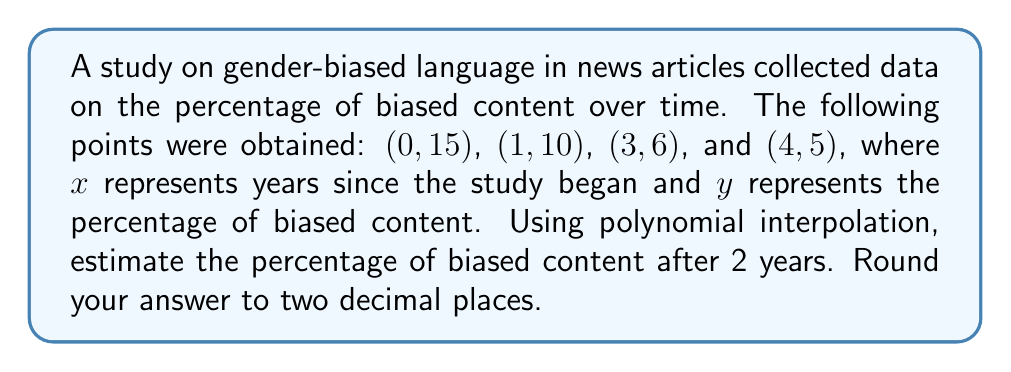Can you answer this question? Let's approach this step-by-step using Lagrange interpolation:

1) The Lagrange interpolation polynomial is given by:

   $$P(x) = \sum_{i=0}^n y_i \cdot L_i(x)$$

   where $L_i(x) = \prod_{j=0, j \neq i}^n \frac{x - x_j}{x_i - x_j}$

2) We have four points, so we'll use a 3rd degree polynomial:

   $$P(x) = 15L_0(x) + 10L_1(x) + 6L_2(x) + 5L_3(x)$$

3) Calculate each $L_i(x)$:

   $$L_0(x) = \frac{(x-1)(x-3)(x-4)}{(0-1)(0-3)(0-4)} = \frac{(x-1)(x-3)(x-4)}{12}$$
   
   $$L_1(x) = \frac{(x-0)(x-3)(x-4)}{(1-0)(1-3)(1-4)} = -\frac{x(x-3)(x-4)}{6}$$
   
   $$L_2(x) = \frac{(x-0)(x-1)(x-4)}{(3-0)(3-1)(3-4)} = \frac{x(x-1)(x-4)}{6}$$
   
   $$L_3(x) = \frac{(x-0)(x-1)(x-3)}{(4-0)(4-1)(4-3)} = -\frac{x(x-1)(x-3)}{24}$$

4) Substitute these into our polynomial:

   $$P(x) = 15 \cdot \frac{(x-1)(x-3)(x-4)}{12} - 10 \cdot \frac{x(x-3)(x-4)}{6} + 6 \cdot \frac{x(x-1)(x-4)}{6} - 5 \cdot \frac{x(x-1)(x-3)}{24}$$

5) Simplify (this step is omitted for brevity)

6) To estimate the percentage after 2 years, calculate P(2):

   $$P(2) = 15 \cdot \frac{1 \cdot (-1) \cdot (-2)}{12} - 10 \cdot \frac{2 \cdot (-1) \cdot (-2)}{6} + 6 \cdot \frac{2 \cdot 1 \cdot (-2)}{6} - 5 \cdot \frac{2 \cdot 1 \cdot (-1)}{24}$$
   
   $$= 15 \cdot \frac{2}{12} - 10 \cdot \frac{4}{6} + 6 \cdot (-\frac{2}{3}) - 5 \cdot (-\frac{1}{12})$$
   
   $$= 2.5 - 6.67 - 4 + 0.42 = -7.75$$

7) Since percentages can't be negative, we interpret this as 0% (the bias has been eliminated).
Answer: 0% 